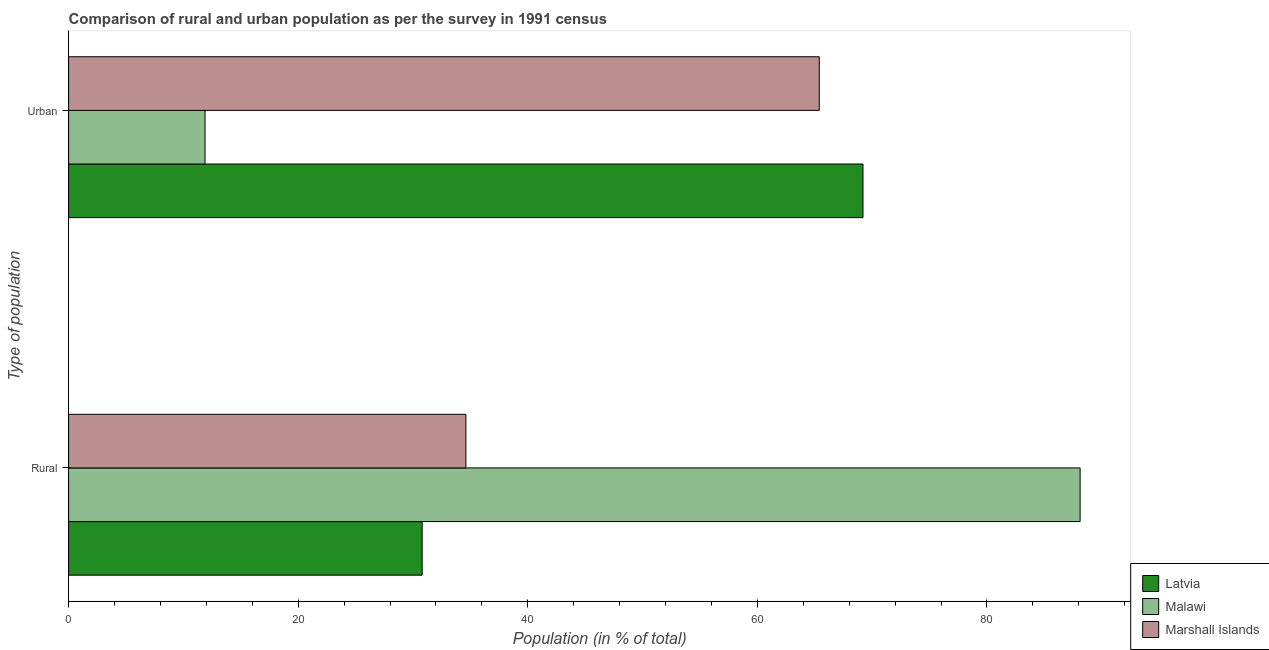How many different coloured bars are there?
Offer a very short reply. 3. How many groups of bars are there?
Offer a terse response. 2. Are the number of bars per tick equal to the number of legend labels?
Provide a succinct answer. Yes. Are the number of bars on each tick of the Y-axis equal?
Provide a succinct answer. Yes. How many bars are there on the 1st tick from the bottom?
Your response must be concise. 3. What is the label of the 1st group of bars from the top?
Provide a short and direct response. Urban. What is the rural population in Marshall Islands?
Offer a terse response. 34.61. Across all countries, what is the maximum urban population?
Make the answer very short. 69.2. Across all countries, what is the minimum rural population?
Ensure brevity in your answer.  30.8. In which country was the urban population maximum?
Provide a short and direct response. Latvia. In which country was the rural population minimum?
Keep it short and to the point. Latvia. What is the total urban population in the graph?
Your answer should be compact. 146.48. What is the difference between the urban population in Malawi and that in Marshall Islands?
Offer a very short reply. -53.51. What is the difference between the urban population in Marshall Islands and the rural population in Latvia?
Offer a terse response. 34.59. What is the average rural population per country?
Provide a succinct answer. 51.17. What is the difference between the urban population and rural population in Latvia?
Your response must be concise. 38.4. What is the ratio of the urban population in Malawi to that in Marshall Islands?
Offer a very short reply. 0.18. Is the urban population in Malawi less than that in Latvia?
Provide a succinct answer. Yes. In how many countries, is the rural population greater than the average rural population taken over all countries?
Make the answer very short. 1. What does the 3rd bar from the top in Urban represents?
Keep it short and to the point. Latvia. What does the 3rd bar from the bottom in Rural represents?
Your answer should be very brief. Marshall Islands. How many bars are there?
Make the answer very short. 6. Are all the bars in the graph horizontal?
Give a very brief answer. Yes. How many countries are there in the graph?
Your response must be concise. 3. Does the graph contain any zero values?
Ensure brevity in your answer.  No. Does the graph contain grids?
Your answer should be compact. No. How many legend labels are there?
Offer a very short reply. 3. How are the legend labels stacked?
Give a very brief answer. Vertical. What is the title of the graph?
Give a very brief answer. Comparison of rural and urban population as per the survey in 1991 census. What is the label or title of the X-axis?
Offer a terse response. Population (in % of total). What is the label or title of the Y-axis?
Keep it short and to the point. Type of population. What is the Population (in % of total) of Latvia in Rural?
Your answer should be compact. 30.8. What is the Population (in % of total) of Malawi in Rural?
Your answer should be compact. 88.11. What is the Population (in % of total) of Marshall Islands in Rural?
Offer a terse response. 34.61. What is the Population (in % of total) in Latvia in Urban?
Offer a very short reply. 69.2. What is the Population (in % of total) in Malawi in Urban?
Keep it short and to the point. 11.88. What is the Population (in % of total) of Marshall Islands in Urban?
Offer a very short reply. 65.39. Across all Type of population, what is the maximum Population (in % of total) in Latvia?
Give a very brief answer. 69.2. Across all Type of population, what is the maximum Population (in % of total) of Malawi?
Provide a short and direct response. 88.11. Across all Type of population, what is the maximum Population (in % of total) of Marshall Islands?
Offer a very short reply. 65.39. Across all Type of population, what is the minimum Population (in % of total) of Latvia?
Offer a terse response. 30.8. Across all Type of population, what is the minimum Population (in % of total) of Malawi?
Offer a terse response. 11.88. Across all Type of population, what is the minimum Population (in % of total) of Marshall Islands?
Keep it short and to the point. 34.61. What is the total Population (in % of total) of Latvia in the graph?
Give a very brief answer. 100. What is the difference between the Population (in % of total) in Latvia in Rural and that in Urban?
Make the answer very short. -38.4. What is the difference between the Population (in % of total) in Malawi in Rural and that in Urban?
Ensure brevity in your answer.  76.23. What is the difference between the Population (in % of total) in Marshall Islands in Rural and that in Urban?
Your answer should be very brief. -30.78. What is the difference between the Population (in % of total) in Latvia in Rural and the Population (in % of total) in Malawi in Urban?
Ensure brevity in your answer.  18.91. What is the difference between the Population (in % of total) of Latvia in Rural and the Population (in % of total) of Marshall Islands in Urban?
Provide a succinct answer. -34.59. What is the difference between the Population (in % of total) of Malawi in Rural and the Population (in % of total) of Marshall Islands in Urban?
Your answer should be very brief. 22.72. What is the average Population (in % of total) of Malawi per Type of population?
Give a very brief answer. 50. What is the average Population (in % of total) in Marshall Islands per Type of population?
Give a very brief answer. 50. What is the difference between the Population (in % of total) in Latvia and Population (in % of total) in Malawi in Rural?
Provide a short and direct response. -57.32. What is the difference between the Population (in % of total) in Latvia and Population (in % of total) in Marshall Islands in Rural?
Ensure brevity in your answer.  -3.81. What is the difference between the Population (in % of total) of Malawi and Population (in % of total) of Marshall Islands in Rural?
Offer a very short reply. 53.51. What is the difference between the Population (in % of total) in Latvia and Population (in % of total) in Malawi in Urban?
Your response must be concise. 57.32. What is the difference between the Population (in % of total) in Latvia and Population (in % of total) in Marshall Islands in Urban?
Your response must be concise. 3.81. What is the difference between the Population (in % of total) of Malawi and Population (in % of total) of Marshall Islands in Urban?
Your answer should be very brief. -53.51. What is the ratio of the Population (in % of total) in Latvia in Rural to that in Urban?
Make the answer very short. 0.45. What is the ratio of the Population (in % of total) in Malawi in Rural to that in Urban?
Your answer should be compact. 7.41. What is the ratio of the Population (in % of total) of Marshall Islands in Rural to that in Urban?
Give a very brief answer. 0.53. What is the difference between the highest and the second highest Population (in % of total) of Latvia?
Provide a short and direct response. 38.4. What is the difference between the highest and the second highest Population (in % of total) of Malawi?
Keep it short and to the point. 76.23. What is the difference between the highest and the second highest Population (in % of total) of Marshall Islands?
Your response must be concise. 30.78. What is the difference between the highest and the lowest Population (in % of total) of Latvia?
Your response must be concise. 38.4. What is the difference between the highest and the lowest Population (in % of total) of Malawi?
Ensure brevity in your answer.  76.23. What is the difference between the highest and the lowest Population (in % of total) in Marshall Islands?
Your answer should be compact. 30.78. 